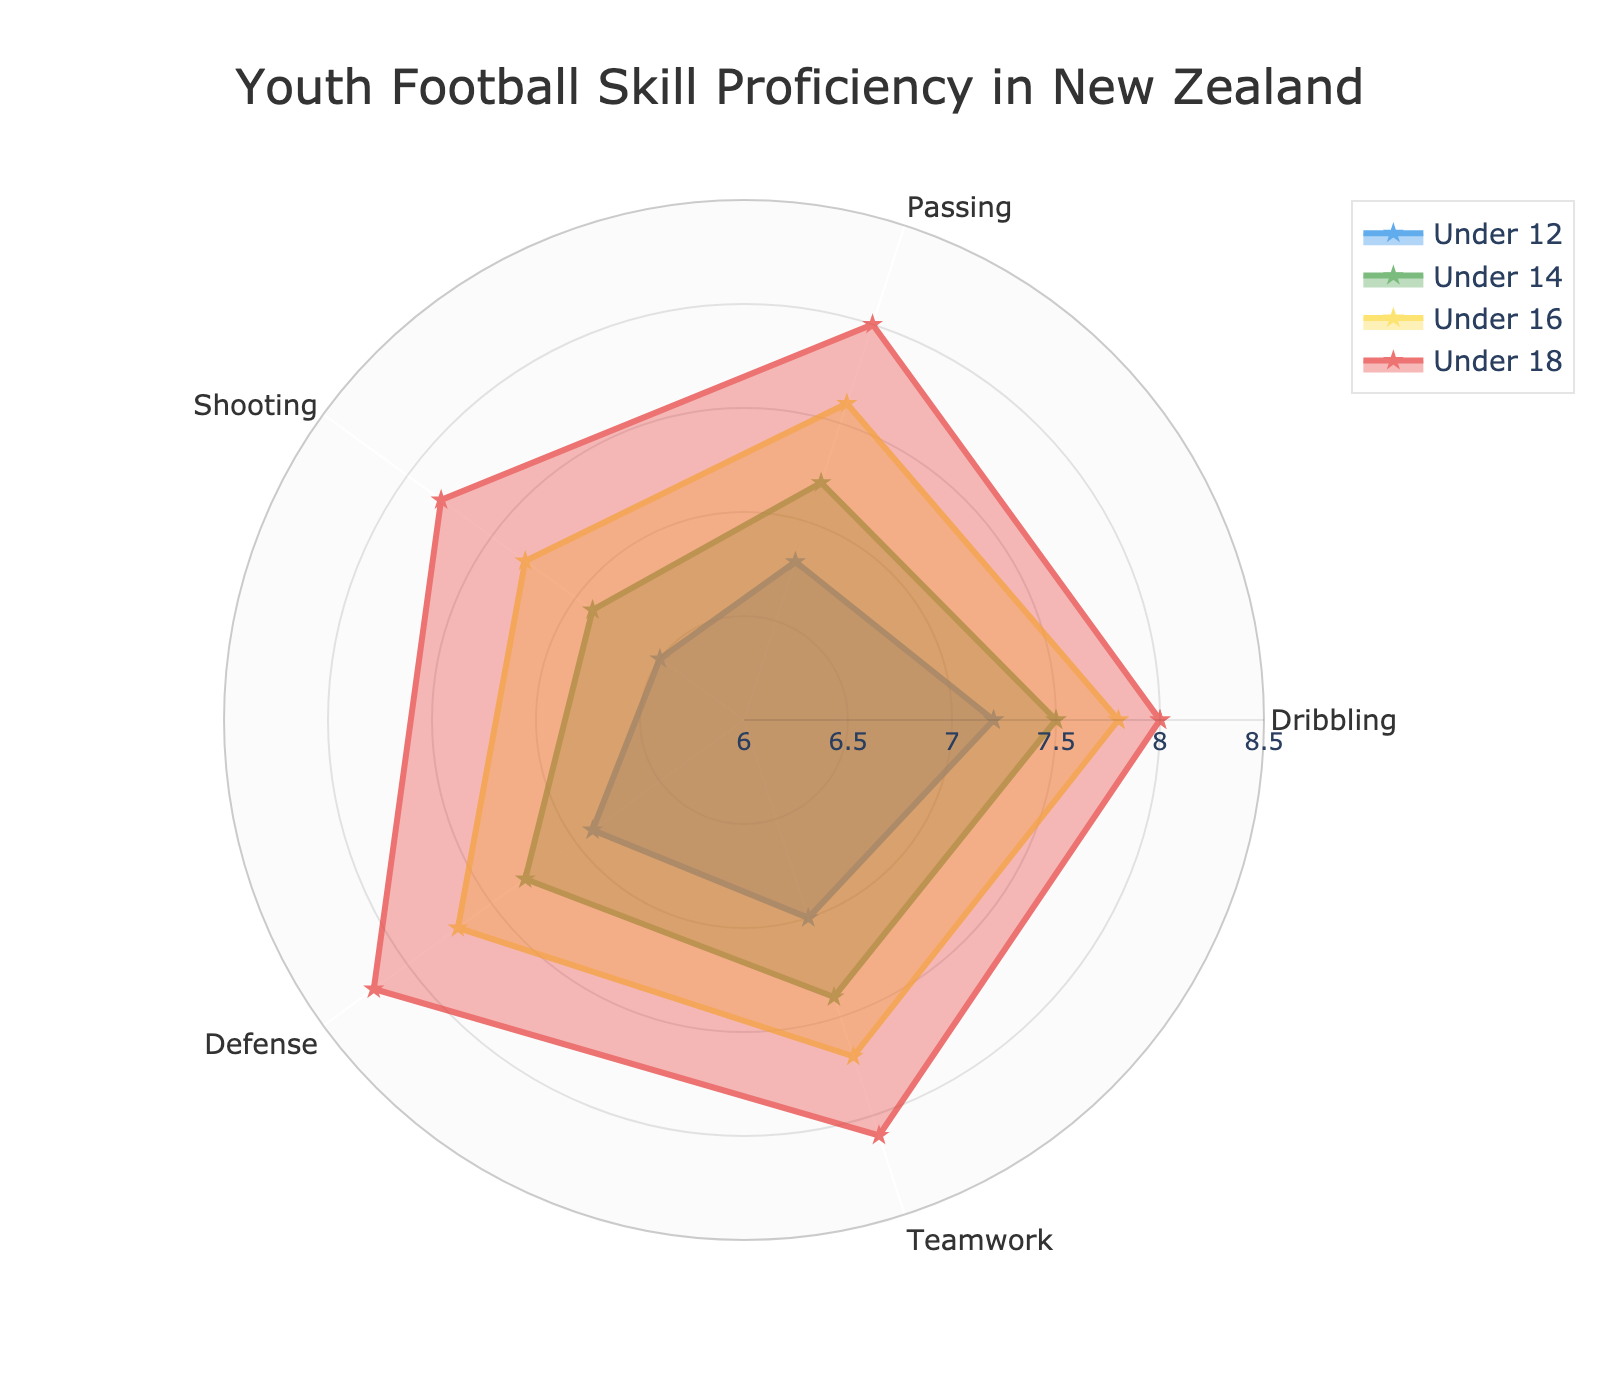What's the title of the chart? The title of the chart is usually found at the top center of the chart where it is prominently displayed. In this case, it is "Youth Football Skill Proficiency in New Zealand".
Answer: Youth Football Skill Proficiency in New Zealand Which age group shows the highest proficiency in Teamwork? From the radar chart, look at the Teamwork category, and observe the radial distances for each age group. The Under 18 group has the highest value.
Answer: Under 18 What is the difference in Dribbling proficiency between Under 12 and Under 18? The Dribbling proficiency for Under 12 is 7.2 and for Under 18 it is 8.0. The difference is calculated by subtracting the Under 12 value from the Under 18 value: 8.0 - 7.2.
Answer: 0.8 Which skill shows the least improvement from Under 12 to Under 18? To determine this, calculate the improvement for each skill by subtracting the Under 12 value from the Under 18 value. The skill with the smallest difference is Shooting (7.8 - 6.5 = 1.3).
Answer: Shooting What is the average proficiency in Defense for the Under 14 and Under 16 age groups? Add the Defense values for Under 14 and Under 16 and divide by 2. (7.3 + 7.7) / 2 = 7.5.
Answer: 7.5 How many age groups are represented in the chart? The age groups are listed in the legend and represented by the different color areas on the radar chart. In this chart, there are four age groups: Under 12, Under 14, Under 16, and Under 18.
Answer: 4 Which skill has the closest proficiency values across all age groups? Examine each skill and note the values across the age groups. Teamwork has values that are relatively close (7.0, 7.4, 7.7, 8.1) compared to other skills.
Answer: Teamwork How does the Defense proficiency change as age increases from Under 12 to Under 18? Observe the values of Defense for each age group sequentially: 6.9 for Under 12, 7.3 for Under 14, 7.7 for Under 16, and 8.2 for Under 18. The proficiency steadily increases with age.
Answer: Increases steadily Is there any skill where the Under 16 age group surpasses the Under 18 age group? Compare the values for Under 16 and Under 18 in each skill. All values for Under 18 are equal to or greater than those for Under 16.
Answer: No 